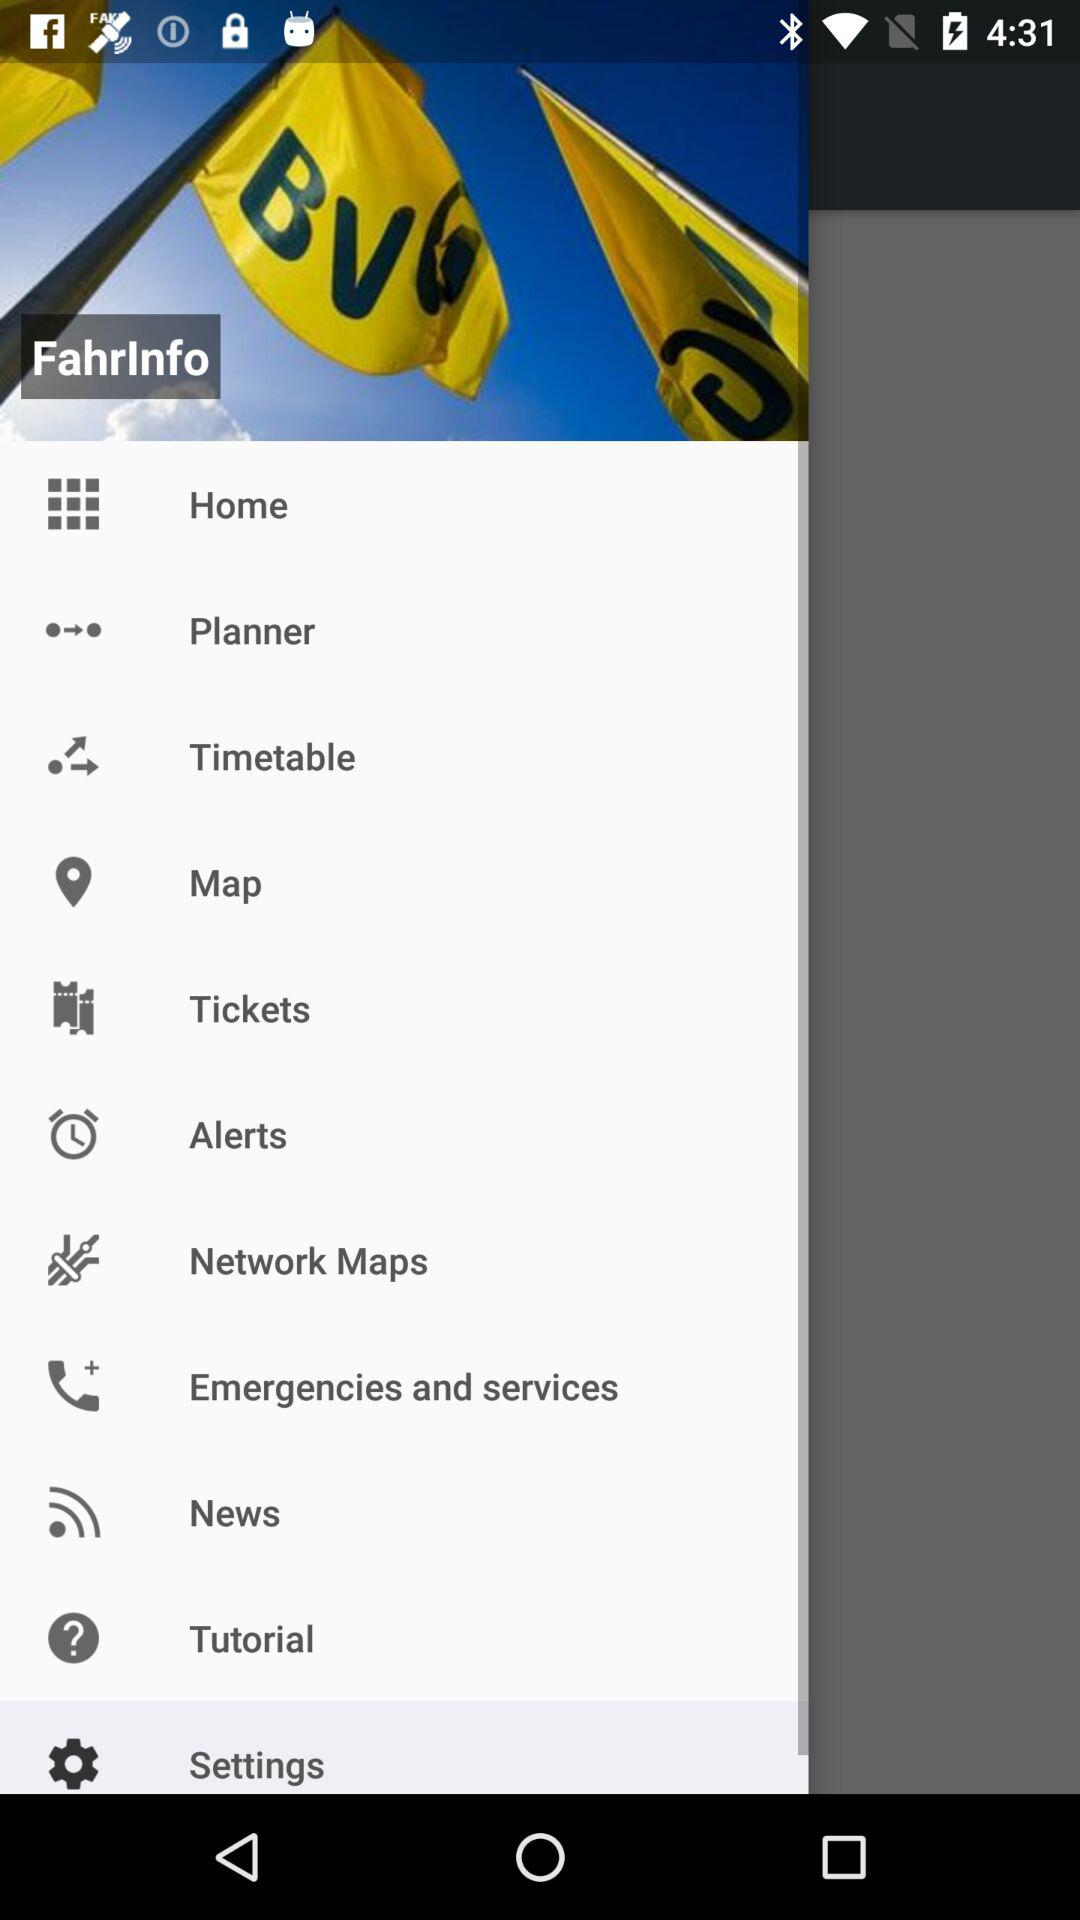How many "Map" options are there?
When the provided information is insufficient, respond with <no answer>. <no answer> 